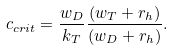<formula> <loc_0><loc_0><loc_500><loc_500>c _ { c r i t } = \frac { w _ { D } } { k _ { T } } \frac { ( w _ { T } + r _ { h } ) } { ( w _ { D } + r _ { h } ) } .</formula> 